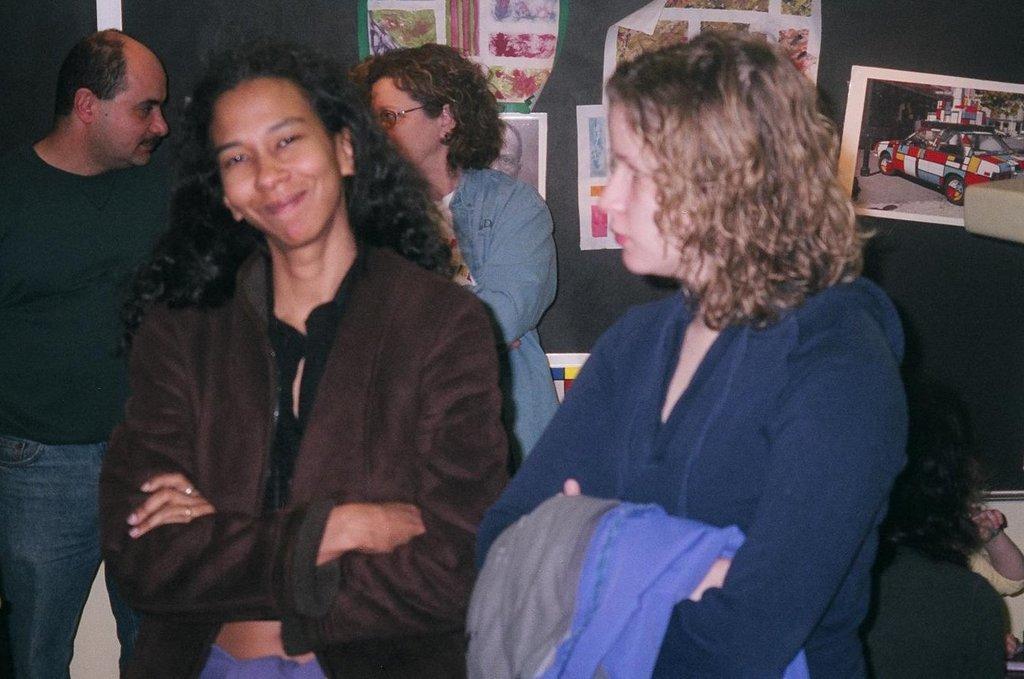Could you give a brief overview of what you see in this image? In this image we can see a group of people standing. In that the woman is holding a cloth. On the backside we can see some people sitting, some papers with the pictures and paintings pasted on a wall. 